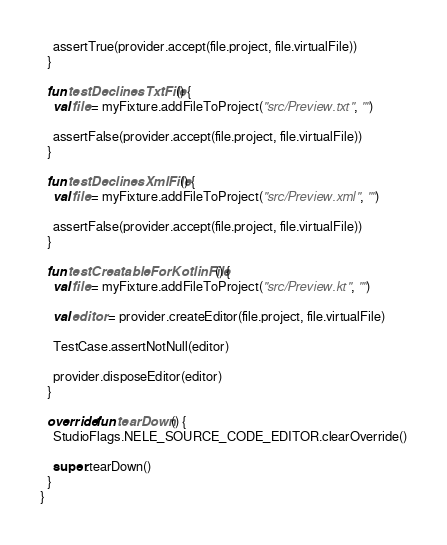Convert code to text. <code><loc_0><loc_0><loc_500><loc_500><_Kotlin_>
    assertTrue(provider.accept(file.project, file.virtualFile))
  }

  fun testDeclinesTxtFile() {
    val file = myFixture.addFileToProject("src/Preview.txt", "")

    assertFalse(provider.accept(file.project, file.virtualFile))
  }

  fun testDeclinesXmlFile() {
    val file = myFixture.addFileToProject("src/Preview.xml", "")

    assertFalse(provider.accept(file.project, file.virtualFile))
  }

  fun testCreatableForKotlinFile() {
    val file = myFixture.addFileToProject("src/Preview.kt", "")

    val editor = provider.createEditor(file.project, file.virtualFile)

    TestCase.assertNotNull(editor)

    provider.disposeEditor(editor)
  }

  override fun tearDown() {
    StudioFlags.NELE_SOURCE_CODE_EDITOR.clearOverride()

    super.tearDown()
  }
}</code> 